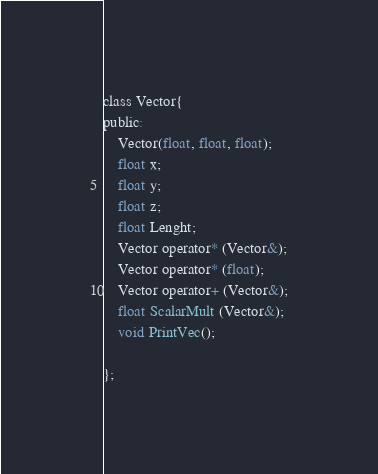Convert code to text. <code><loc_0><loc_0><loc_500><loc_500><_C_>class Vector{
public:
    Vector(float, float, float);
    float x;
    float y;
    float z;
    float Lenght;
    Vector operator* (Vector&);
    Vector operator* (float);
    Vector operator+ (Vector&);
    float ScalarMult (Vector&);
    void PrintVec();

};
</code> 